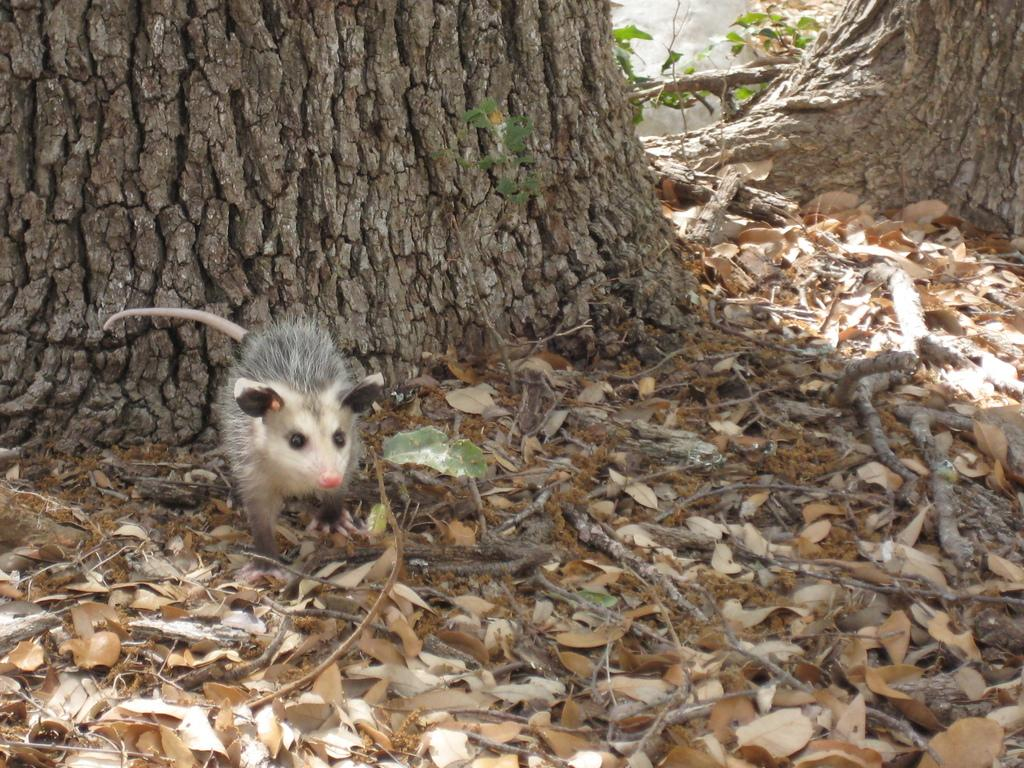What type of animal can be seen in the image? There is a rat in the image. What natural object is present in the image? There is a tree trunk in the image. What type of vegetation can be seen on the ground in the image? Dried leaves are present on the ground in the image. What type of linen is draped over the rat's body? There is no linen present in the image; it features a rat and other natural elements. 